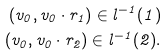<formula> <loc_0><loc_0><loc_500><loc_500>( v _ { 0 } , v _ { 0 } \cdot r _ { 1 } ) \in l ^ { - 1 } ( 1 ) \\ ( v _ { 0 } , v _ { 0 } \cdot r _ { 2 } ) \in l ^ { - 1 } ( 2 ) .</formula> 